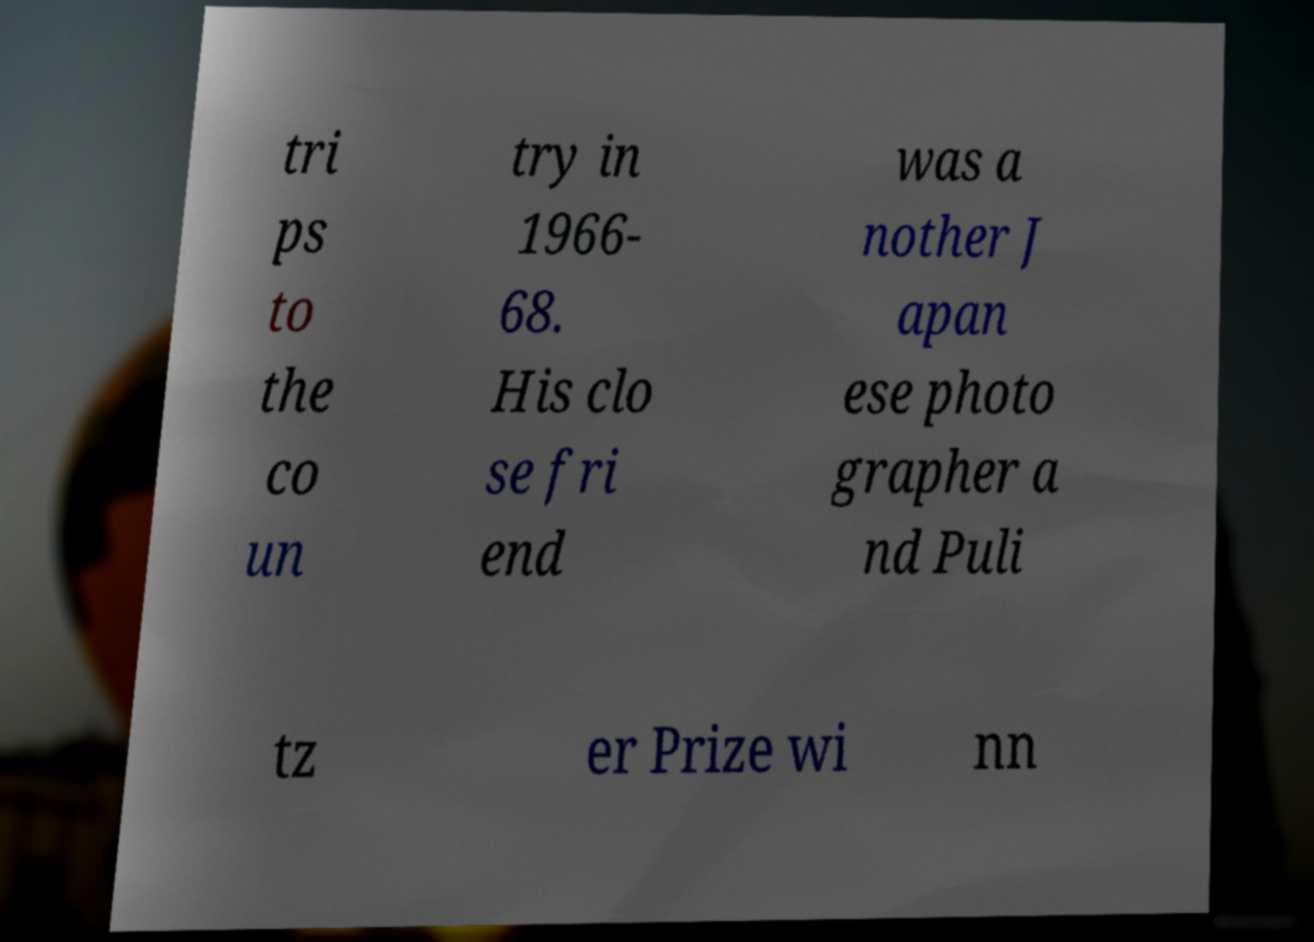Could you assist in decoding the text presented in this image and type it out clearly? tri ps to the co un try in 1966- 68. His clo se fri end was a nother J apan ese photo grapher a nd Puli tz er Prize wi nn 